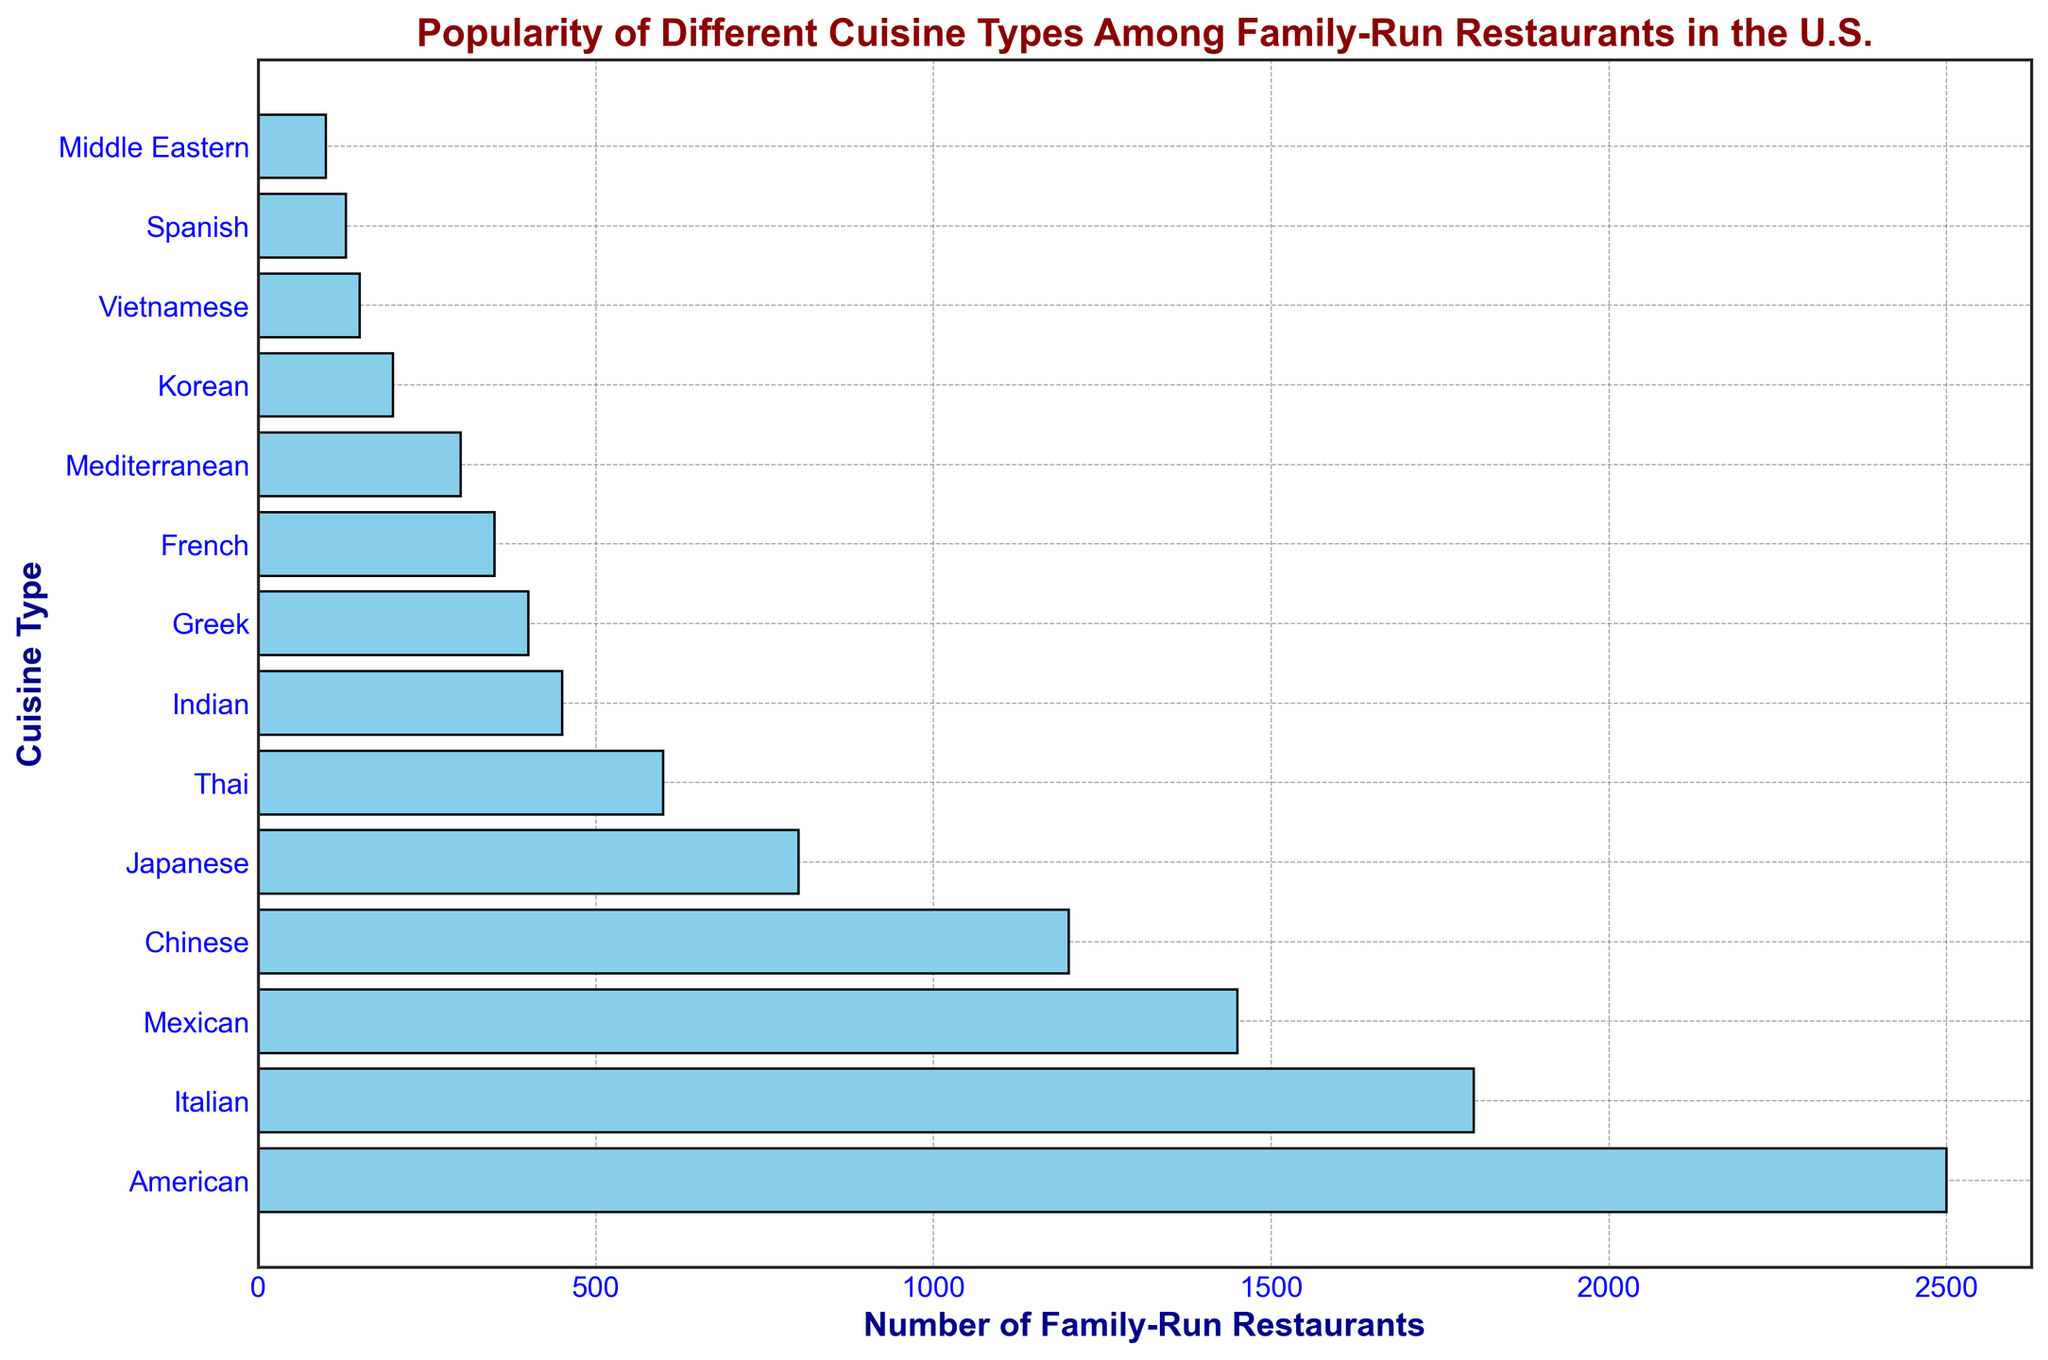Which cuisine type is the most popular among family-run restaurants in the U.S.? The figure shows a bar chart representing the number of family-run restaurants for different cuisine types. The longest bar represents the cuisine type with the highest number of restaurants. In this case, the American cuisine bar is the longest.
Answer: American How many more family-run Italian restaurants are there compared to Greek restaurants? To find the difference, locate the bars for Italian and Greek cuisines on the chart. The Italian bar points to 1800 and the Greek bar points to 400. Subtract the two values: 1800 - 400.
Answer: 1400 What is the total number of family-run Mexican, Chinese, and Thai restaurants? Identify the bars for Mexican (1450), Chinese (1200), and Thai (600) cuisines. Add the values together: 1450 + 1200 + 600.
Answer: 3250 Which cuisine type has fewer family-run restaurants: French or Korean? Compare the length of the bars for French and Korean cuisines. The French bar points to 350, and the Korean bar points to 200. The Korean bar is shorter.
Answer: Korean What is the average number of family-run restaurants for Japanese, Indian, and Spanish cuisines? Identify the bars for Japanese (800), Indian (450), and Spanish (130) cuisines. Add the values and divide by the number of cuisines: (800 + 450 + 130) / 3.
Answer: 460 How much higher is the number of family-run American restaurants compared to family-run Vietnamese restaurants? Locate the bars for American (2500) and Vietnamese (150) cuisines. Subtract the Vietnamese value from the American value: 2500 - 150.
Answer: 2350 Which cuisine type has the second highest number of family-run restaurants? Identify the bars with the top two highest values. The American cuisine has the highest (2500) and Italian cuisine has the second highest (1800).
Answer: Italian What is the combined number of family-run Greek and Mediterranean restaurants? Identify the bars for Greek (400) and Mediterranean (300) cuisines. Add the values together: 400 + 300.
Answer: 700 Is the number of family-run Indian restaurants greater than Spanish and Middle Eastern restaurants combined? Identify the bars for Indian (450), Spanish (130), and Middle Eastern (100) cuisines. Add the Spanish and Middle Eastern values: 130 + 100 = 230. Compare with the Indian value: 450 > 230.
Answer: Yes Which cuisine type forms the smallest group of family-run restaurants in the provided data? The shortest bar in the bar chart represents the cuisine type with the lowest number of restaurants. The Middle Eastern cuisine bar is the shortest with 100 restaurants.
Answer: Middle Eastern 